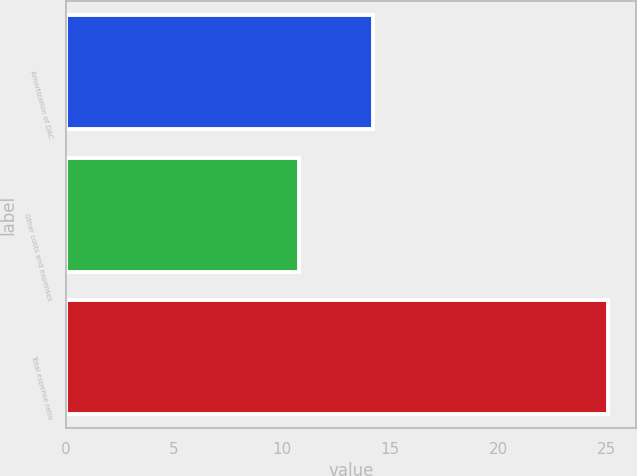<chart> <loc_0><loc_0><loc_500><loc_500><bar_chart><fcel>Amortization of DAC<fcel>Other costs and expenses<fcel>Total expense ratio<nl><fcel>14.2<fcel>10.8<fcel>25.1<nl></chart> 